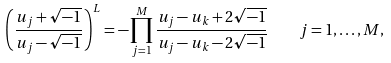Convert formula to latex. <formula><loc_0><loc_0><loc_500><loc_500>\left ( \frac { u _ { j } + \sqrt { - 1 } } { u _ { j } - \sqrt { - 1 } } \right ) ^ { L } = - \prod _ { j = 1 } ^ { M } \frac { u _ { j } - u _ { k } + 2 \sqrt { - 1 } } { u _ { j } - u _ { k } - 2 \sqrt { - 1 } } \quad j = 1 , \dots , M ,</formula> 